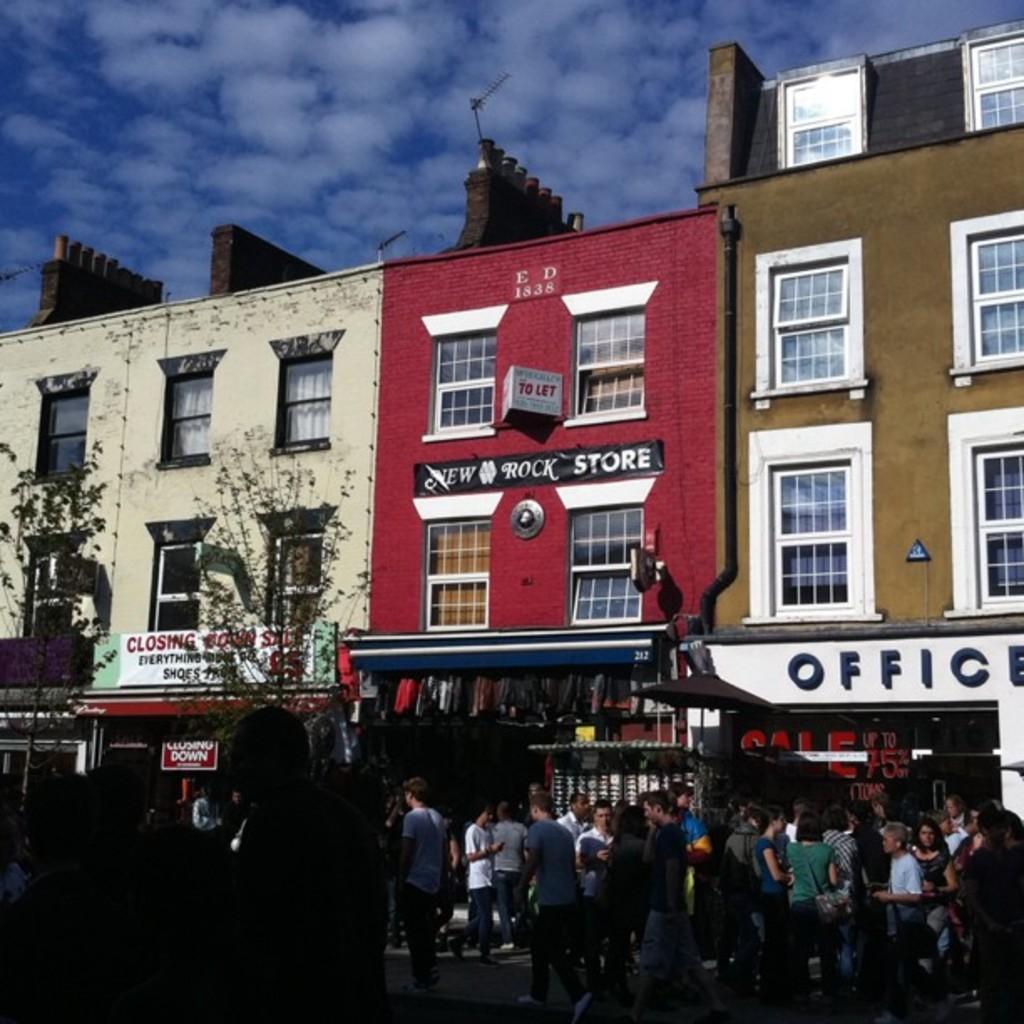Can you describe this image briefly? In this image there are a few people walking on the streets, behind them there are trees and buildings, in front of the buildings there are shops with name boards on it, at the top of the building there are antennas, at the top of the image there are clouds in the sky. 